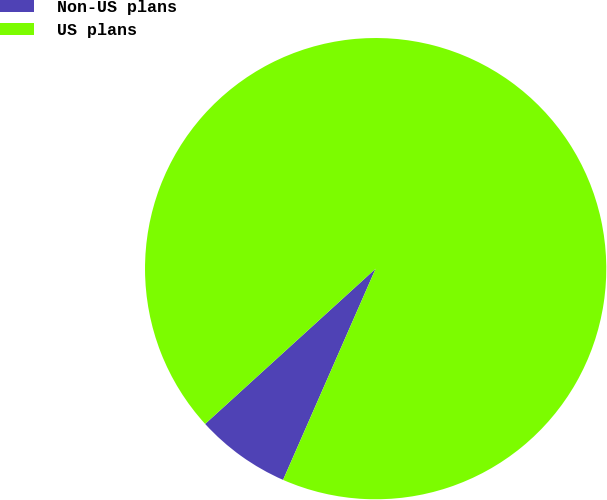Convert chart. <chart><loc_0><loc_0><loc_500><loc_500><pie_chart><fcel>Non-US plans<fcel>US plans<nl><fcel>6.67%<fcel>93.33%<nl></chart> 